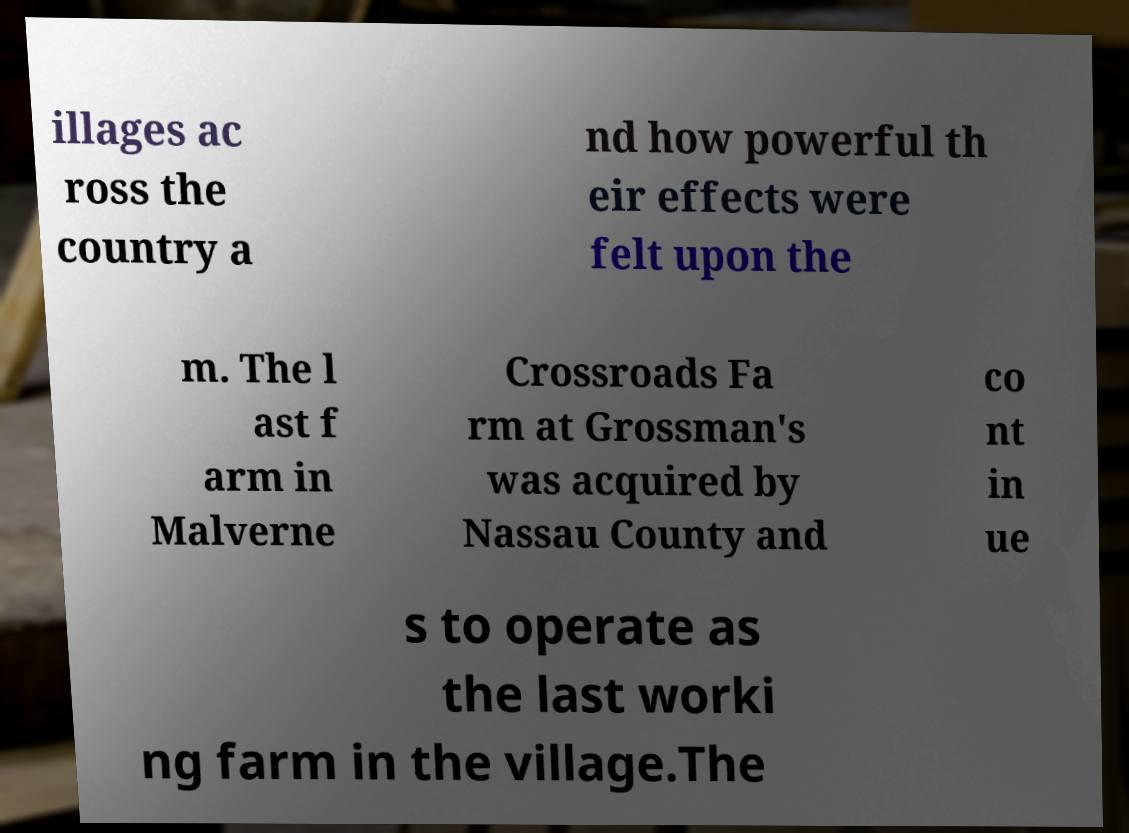Please identify and transcribe the text found in this image. illages ac ross the country a nd how powerful th eir effects were felt upon the m. The l ast f arm in Malverne Crossroads Fa rm at Grossman's was acquired by Nassau County and co nt in ue s to operate as the last worki ng farm in the village.The 